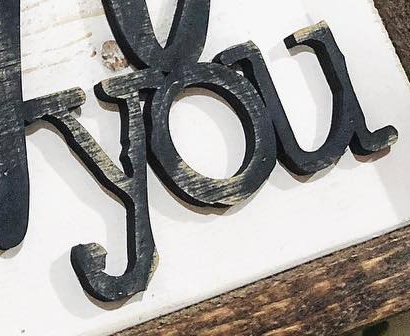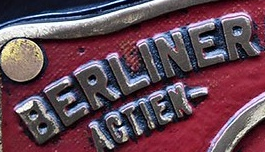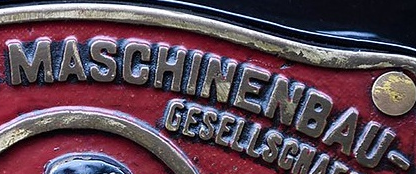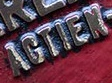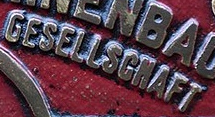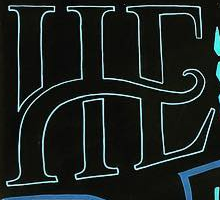Identify the words shown in these images in order, separated by a semicolon. you; BERLINER; MASCHINENBAU; AGTIEN; GESELLSGNAFT; HE 